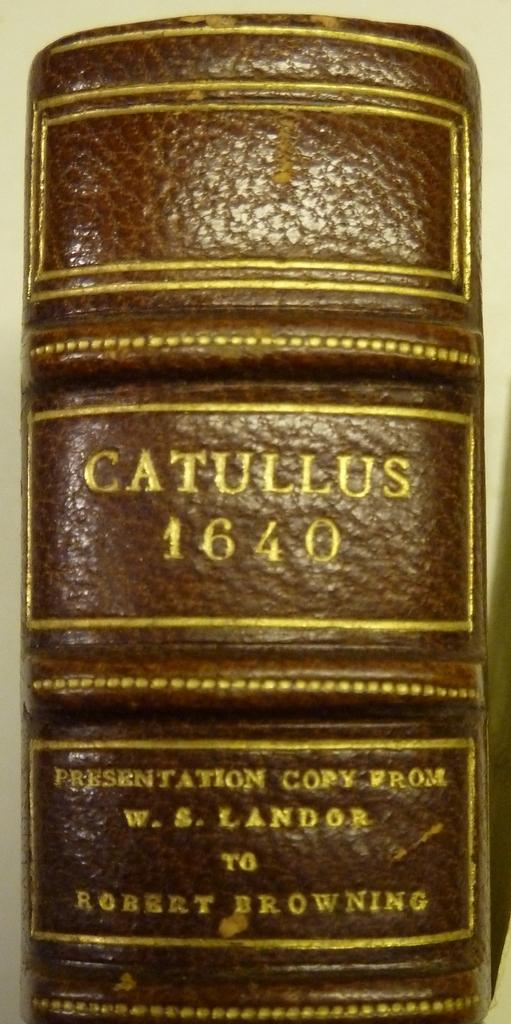Provide a one-sentence caption for the provided image. The leather bound spine of catullus 1640 written by w. s. Landor. 